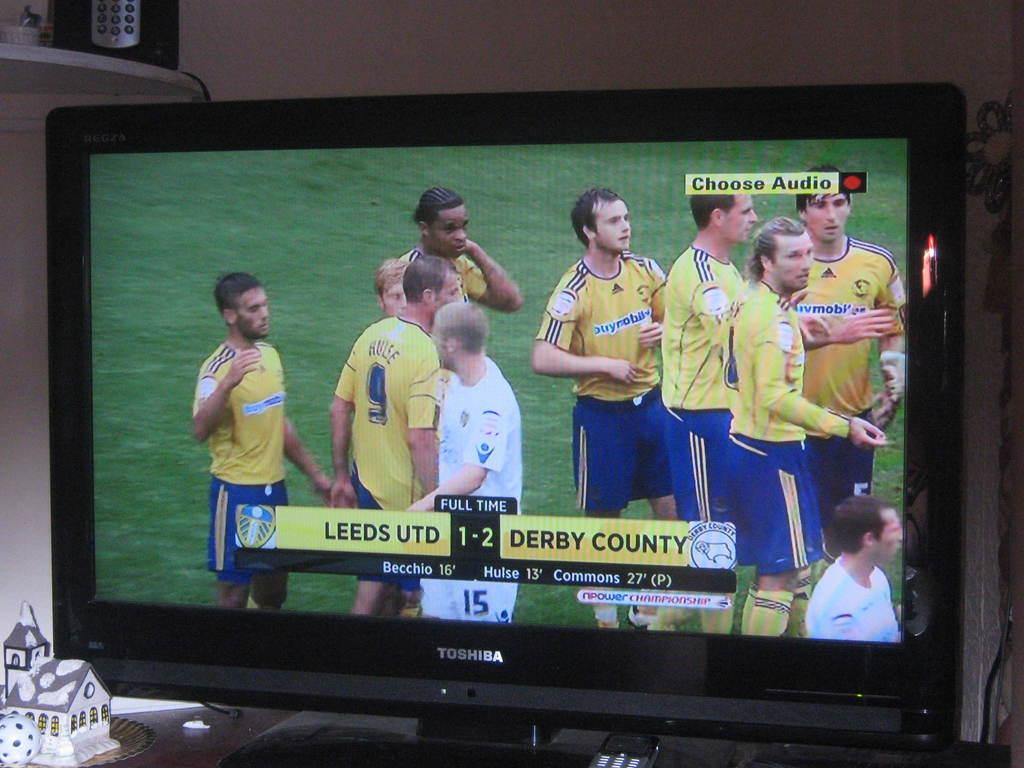<image>
Share a concise interpretation of the image provided. A TV showing the game Leeds UTD vs. Derby County with a score of 1-2. 